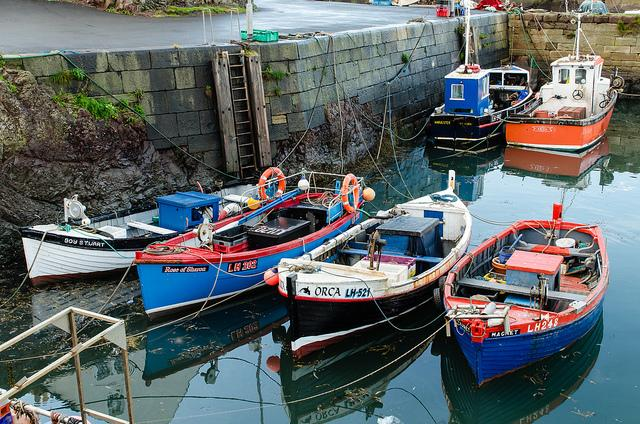What is available to get from the boats to the ground level? ladder 